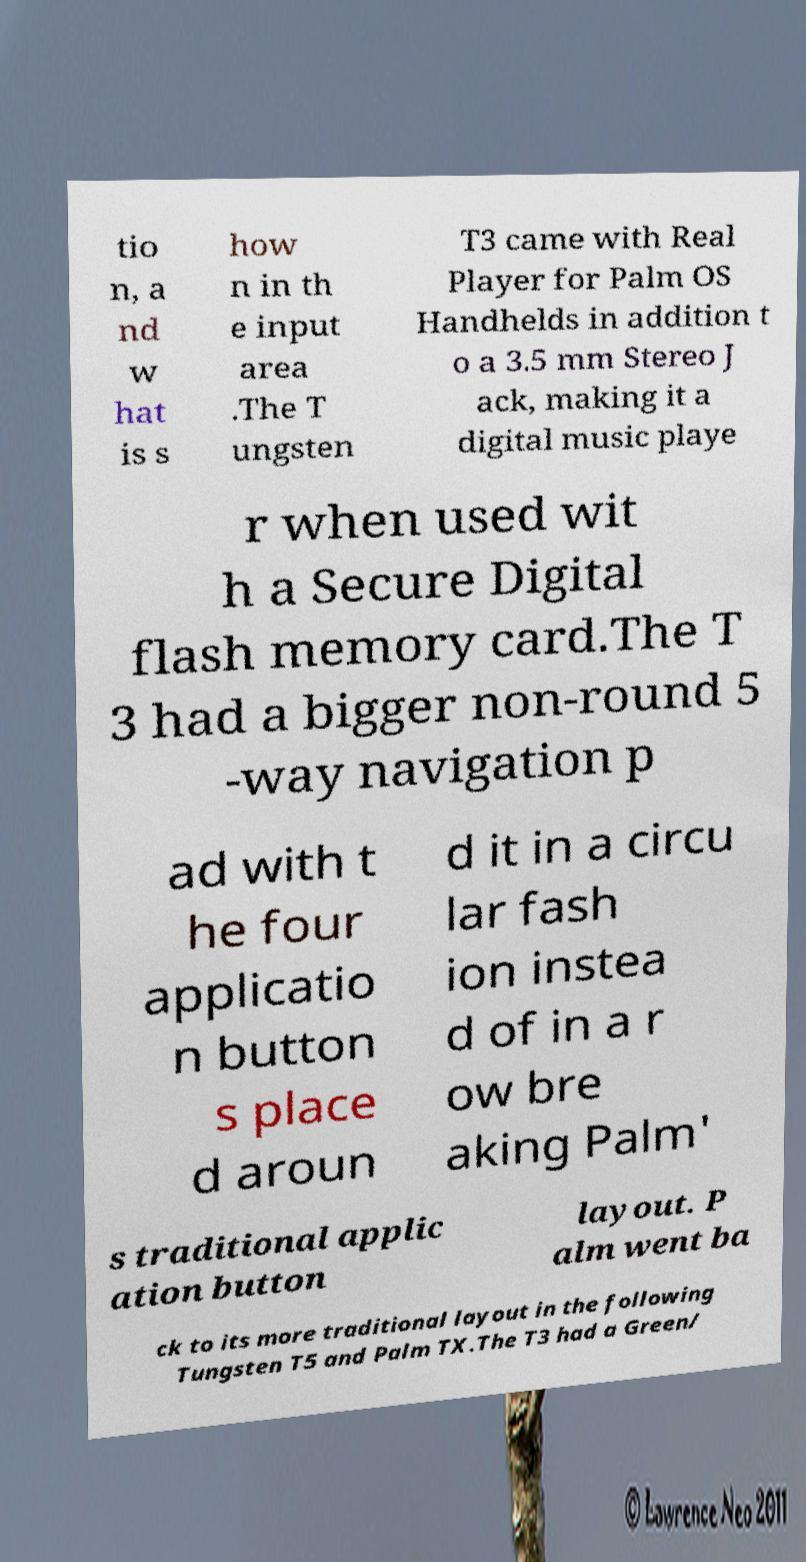I need the written content from this picture converted into text. Can you do that? tio n, a nd w hat is s how n in th e input area .The T ungsten T3 came with Real Player for Palm OS Handhelds in addition t o a 3.5 mm Stereo J ack, making it a digital music playe r when used wit h a Secure Digital flash memory card.The T 3 had a bigger non-round 5 -way navigation p ad with t he four applicatio n button s place d aroun d it in a circu lar fash ion instea d of in a r ow bre aking Palm' s traditional applic ation button layout. P alm went ba ck to its more traditional layout in the following Tungsten T5 and Palm TX.The T3 had a Green/ 